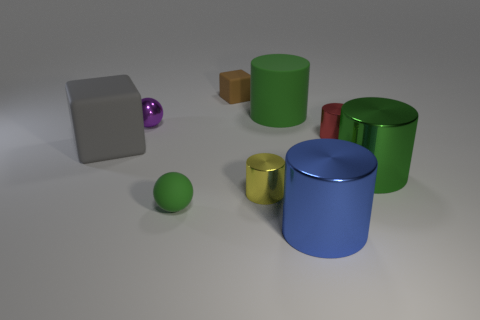Subtract all yellow cylinders. How many cylinders are left? 4 Subtract all gray cylinders. Subtract all yellow balls. How many cylinders are left? 5 Add 1 large green matte cylinders. How many objects exist? 10 Subtract all spheres. How many objects are left? 7 Subtract 0 cyan cylinders. How many objects are left? 9 Subtract all small cyan things. Subtract all small brown blocks. How many objects are left? 8 Add 7 matte cylinders. How many matte cylinders are left? 8 Add 3 large gray things. How many large gray things exist? 4 